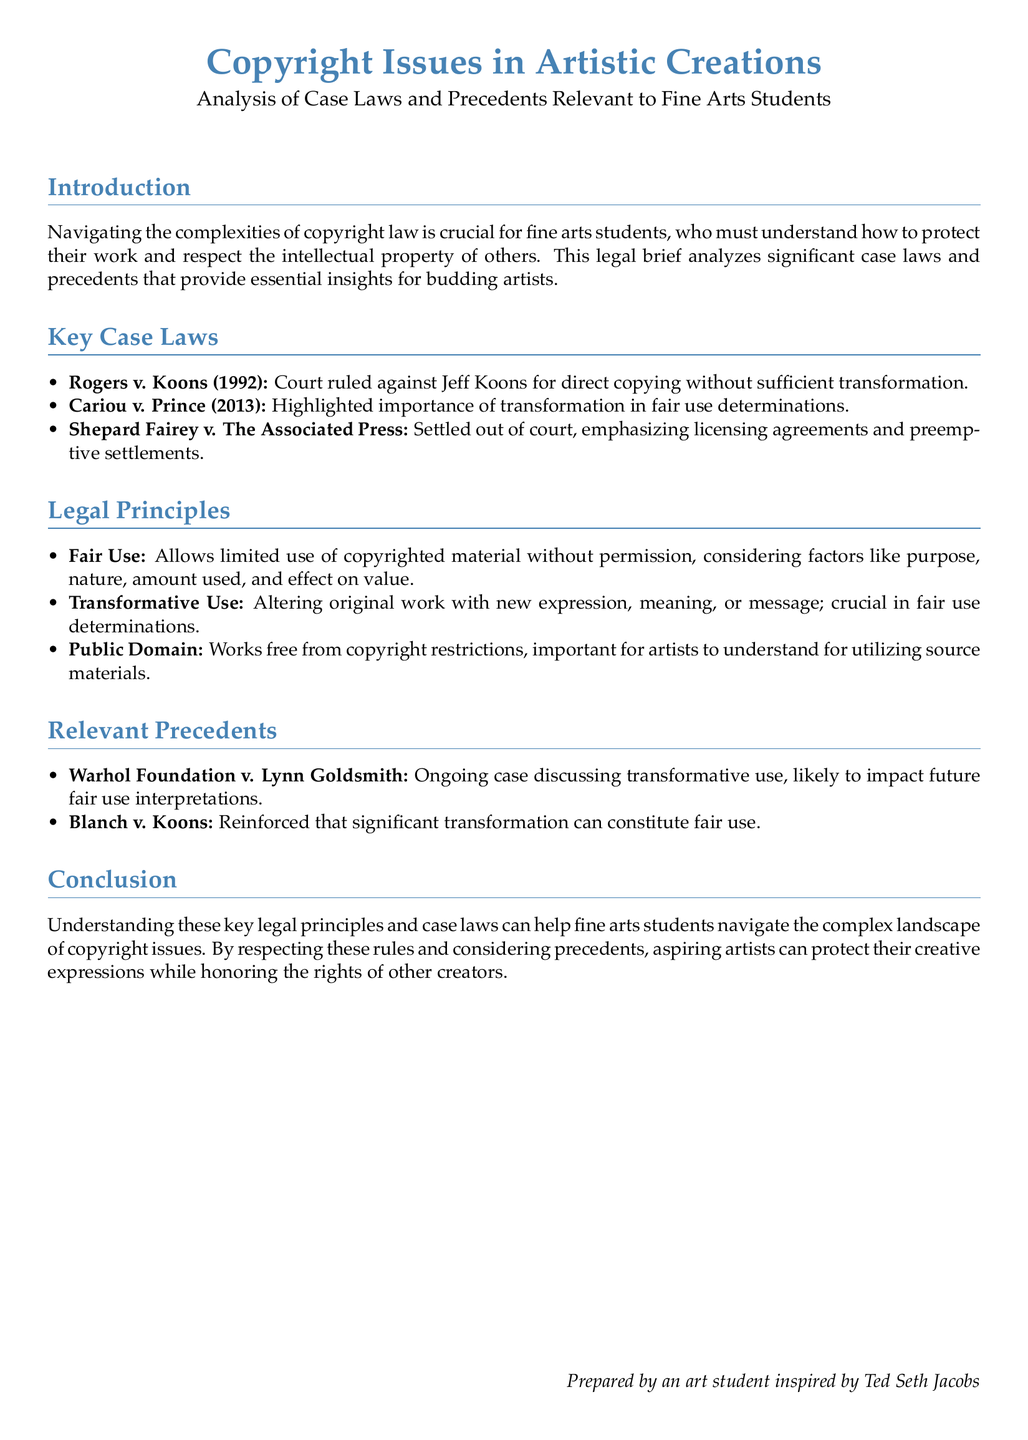What is the title of the document? The title of the document is presented prominently at the beginning, summarizing its main focus on copyright issues in artistic creations.
Answer: Copyright Issues in Artistic Creations What year was the case Rogers v. Koons decided? The year when the case was resolved is provided in parentheses immediately following the case title in the key case laws section.
Answer: 1992 What is the main legal principle emphasized in Cariou v. Prince? This case highlights an essential concept related to the use of copyrighted material that is significant for artists.
Answer: Transformation Who is the legal brief prepared by? The document ends with a note about the author's background, indicating their connection to a well-known figure in the art community.
Answer: An art student inspired by Ted Seth Jacobs What ongoing case is mentioned regarding transformative use? The brief references a current legal battle that may influence future interpretations of a specific concept in copyright law.
Answer: Warhol Foundation v. Lynn Goldsmith Which legal principle allows limited use of copyrighted material? This principle is crucial for artists to understand and is highlighted in the legal principles section of the document.
Answer: Fair Use How many key case laws are listed in the document? This refers to the total number of significant cases discussed that provide insights on copyright issues relevant to fine arts students.
Answer: Three What topic do the listed legal principles primarily focus on? The legal principles section covers a specific aspect of law that is especially relevant for students in the fine arts field.
Answer: Copyright 